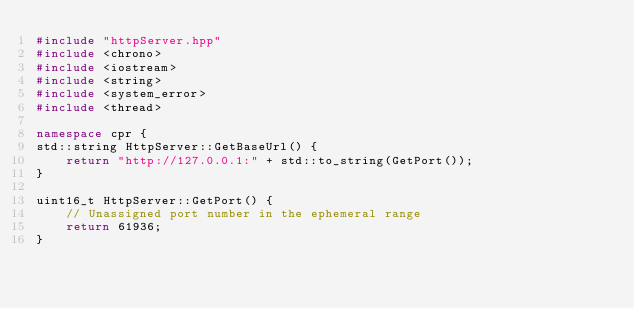Convert code to text. <code><loc_0><loc_0><loc_500><loc_500><_C++_>#include "httpServer.hpp"
#include <chrono>
#include <iostream>
#include <string>
#include <system_error>
#include <thread>

namespace cpr {
std::string HttpServer::GetBaseUrl() {
    return "http://127.0.0.1:" + std::to_string(GetPort());
}

uint16_t HttpServer::GetPort() {
    // Unassigned port number in the ephemeral range
    return 61936;
}
</code> 